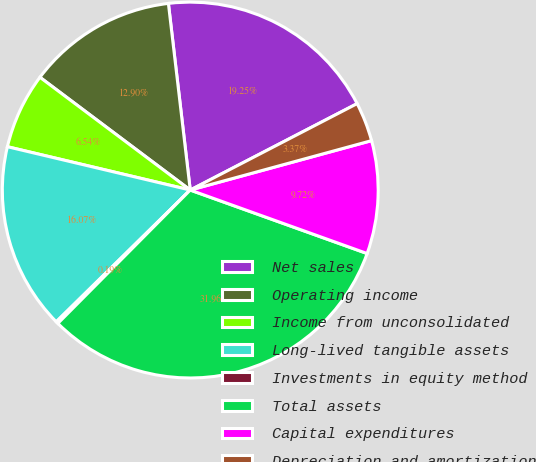<chart> <loc_0><loc_0><loc_500><loc_500><pie_chart><fcel>Net sales<fcel>Operating income<fcel>Income from unconsolidated<fcel>Long-lived tangible assets<fcel>Investments in equity method<fcel>Total assets<fcel>Capital expenditures<fcel>Depreciation and amortization<nl><fcel>19.25%<fcel>12.9%<fcel>6.54%<fcel>16.07%<fcel>0.19%<fcel>31.96%<fcel>9.72%<fcel>3.37%<nl></chart> 